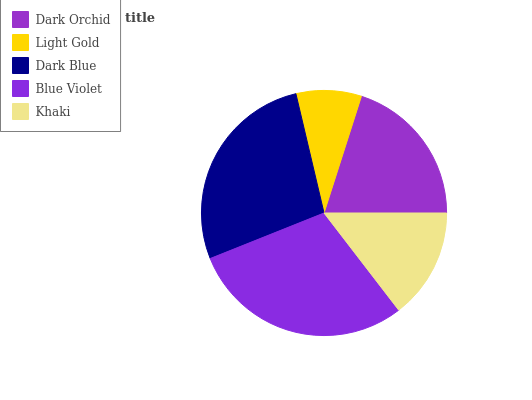Is Light Gold the minimum?
Answer yes or no. Yes. Is Blue Violet the maximum?
Answer yes or no. Yes. Is Dark Blue the minimum?
Answer yes or no. No. Is Dark Blue the maximum?
Answer yes or no. No. Is Dark Blue greater than Light Gold?
Answer yes or no. Yes. Is Light Gold less than Dark Blue?
Answer yes or no. Yes. Is Light Gold greater than Dark Blue?
Answer yes or no. No. Is Dark Blue less than Light Gold?
Answer yes or no. No. Is Dark Orchid the high median?
Answer yes or no. Yes. Is Dark Orchid the low median?
Answer yes or no. Yes. Is Khaki the high median?
Answer yes or no. No. Is Khaki the low median?
Answer yes or no. No. 